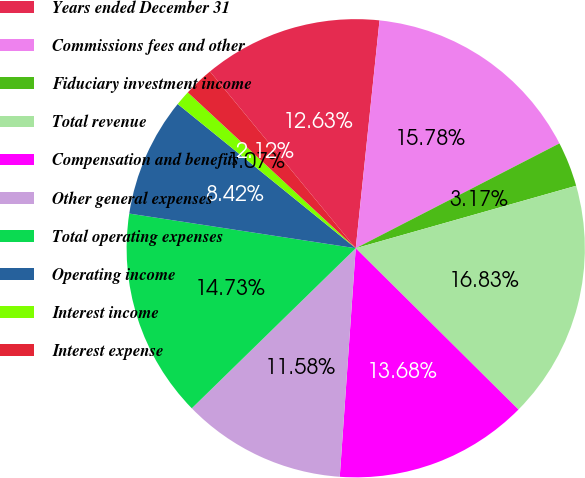Convert chart. <chart><loc_0><loc_0><loc_500><loc_500><pie_chart><fcel>Years ended December 31<fcel>Commissions fees and other<fcel>Fiduciary investment income<fcel>Total revenue<fcel>Compensation and benefits<fcel>Other general expenses<fcel>Total operating expenses<fcel>Operating income<fcel>Interest income<fcel>Interest expense<nl><fcel>12.63%<fcel>15.78%<fcel>3.17%<fcel>16.83%<fcel>13.68%<fcel>11.58%<fcel>14.73%<fcel>8.42%<fcel>1.07%<fcel>2.12%<nl></chart> 